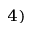<formula> <loc_0><loc_0><loc_500><loc_500>^ { 4 ) }</formula> 